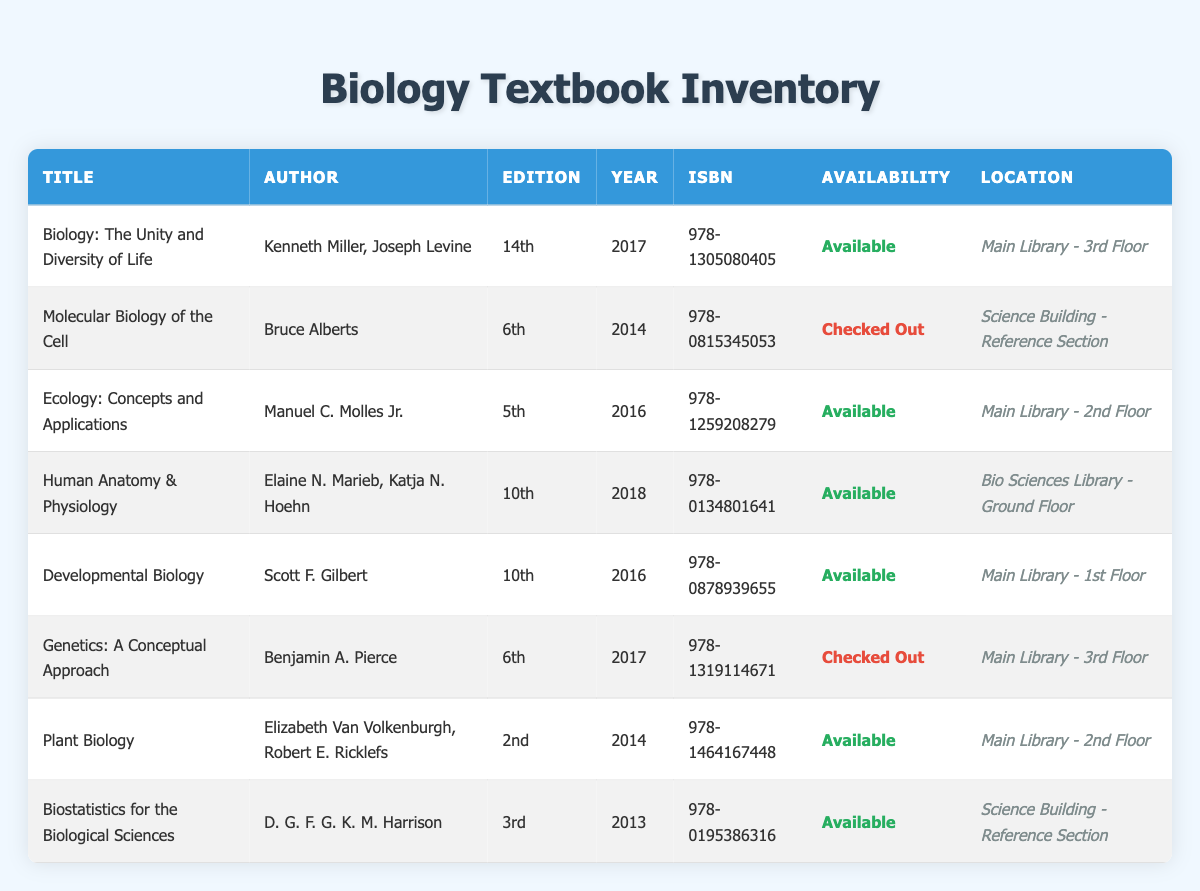What is the title of the book authored by Kenneth Miller and Joseph Levine? The book authored by Kenneth Miller and Joseph Levine can be found by searching the "Author" column for those names. In the table, the title listed alongside those authors is "Biology: The Unity and Diversity of Life."
Answer: Biology: The Unity and Diversity of Life How many textbooks are currently checked out? To find the number of checked-out textbooks, you need to look at the "Availability" column and count how many entries say "Checked Out." In the table, there are two such entries: "Molecular Biology of the Cell" and "Genetics: A Conceptual Approach."
Answer: 2 Which textbook is located on the ground floor of the Bio Sciences Library? The location of textbooks is specified in the "Location" column. Here, "Human Anatomy & Physiology" is the only textbook listed as being in the "Bio Sciences Library - Ground Floor."
Answer: Human Anatomy & Physiology What is the average publication year of the available textbooks? To calculate the average publication year of the available textbooks, first identify the relevant titles. The available textbooks are: "Biology: The Unity and Diversity of Life" (2017), "Ecology: Concepts and Applications" (2016), "Human Anatomy & Physiology" (2018), "Developmental Biology" (2016), "Plant Biology" (2014), and "Biostatistics for the Biological Sciences" (2013). This gives us the years: 2017, 2016, 2018, 2016, 2014, and 2013. Adding these years results in 2017 + 2016 + 2018 + 2016 + 2014 + 2013 = 12094. Dividing by the number of available titles, 6, gives an average of 2017.33, which rounds to 2017.
Answer: 2017 Is "Ecology: Concepts and Applications" available? To determine if "Ecology: Concepts and Applications" is available, you can search for the title in the "Title" column and then check the corresponding "Availability" status. According to the table, this title has "Available" listed next to it.
Answer: Yes Which textbook has the earliest publication year available in the inventory? To find the earliest publication year, examine the "Year" column for all entries. The years listed are 2013, 2014, 2014, 2016, 2016, 2017, 2017, and 2018. The earliest year here is 2013, corresponding to "Biostatistics for the Biological Sciences."
Answer: Biostatistics for the Biological Sciences 